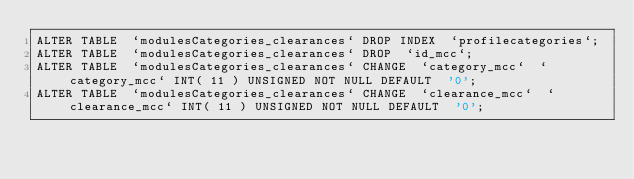Convert code to text. <code><loc_0><loc_0><loc_500><loc_500><_SQL_>ALTER TABLE  `modulesCategories_clearances` DROP INDEX  `profilecategories`;
ALTER TABLE  `modulesCategories_clearances` DROP  `id_mcc`;
ALTER TABLE  `modulesCategories_clearances` CHANGE  `category_mcc`  `category_mcc` INT( 11 ) UNSIGNED NOT NULL DEFAULT  '0';
ALTER TABLE  `modulesCategories_clearances` CHANGE  `clearance_mcc`  `clearance_mcc` INT( 11 ) UNSIGNED NOT NULL DEFAULT  '0';</code> 